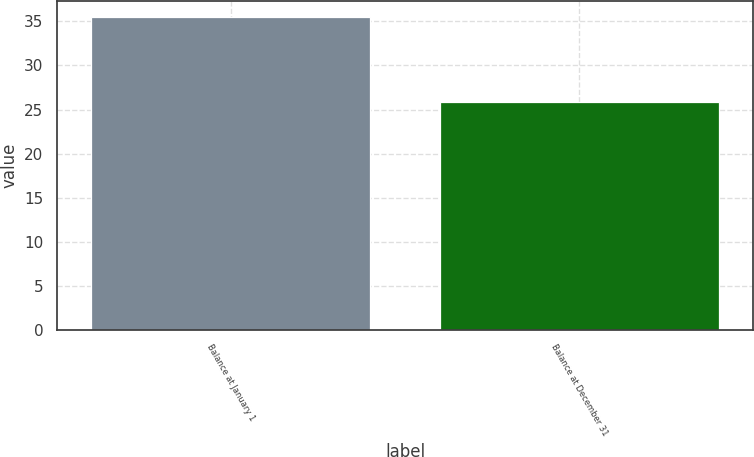Convert chart to OTSL. <chart><loc_0><loc_0><loc_500><loc_500><bar_chart><fcel>Balance at January 1<fcel>Balance at December 31<nl><fcel>35.5<fcel>25.9<nl></chart> 